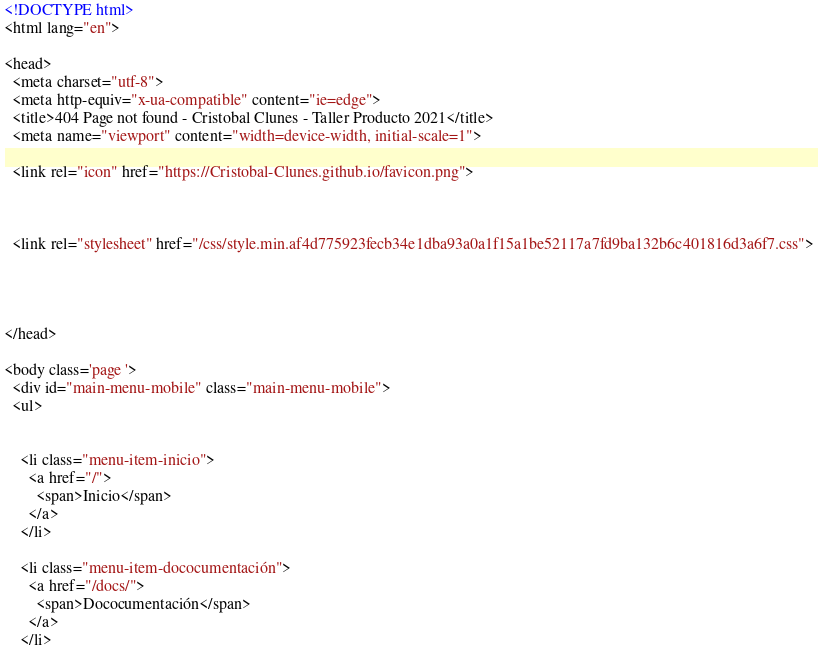Convert code to text. <code><loc_0><loc_0><loc_500><loc_500><_HTML_><!DOCTYPE html>
<html lang="en">

<head>
  <meta charset="utf-8">
  <meta http-equiv="x-ua-compatible" content="ie=edge">
  <title>404 Page not found - Cristobal Clunes - Taller Producto 2021</title>
  <meta name="viewport" content="width=device-width, initial-scale=1">
  
  <link rel="icon" href="https://Cristobal-Clunes.github.io/favicon.png">

  
  
  <link rel="stylesheet" href="/css/style.min.af4d775923fecb34e1dba93a0a1f15a1be52117a7fd9ba132b6c401816d3a6f7.css">
  

  

</head>

<body class='page '>
  <div id="main-menu-mobile" class="main-menu-mobile">
  <ul>
    
    
    <li class="menu-item-inicio">
      <a href="/">
        <span>Inicio</span>
      </a>
    </li>
    
    <li class="menu-item-dococumentación">
      <a href="/docs/">
        <span>Dococumentación</span>
      </a>
    </li></code> 